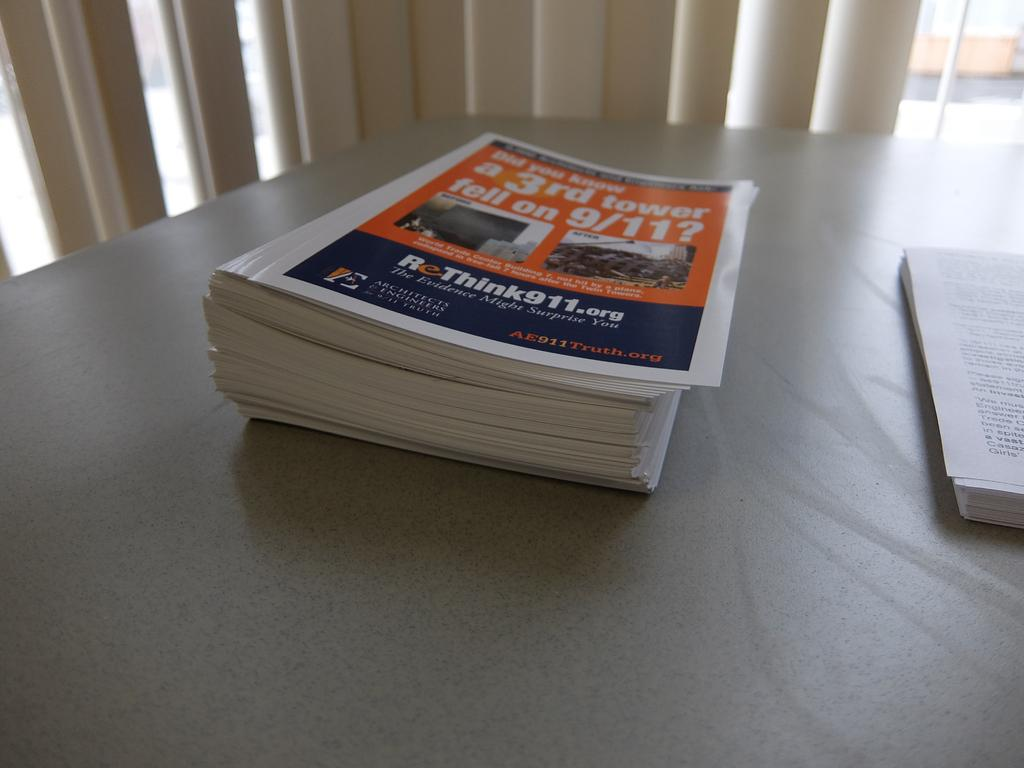<image>
Describe the image concisely. A stack of books about a third tower on 9/11 are on a table. 